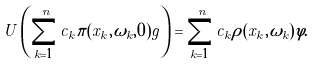<formula> <loc_0><loc_0><loc_500><loc_500>U \left ( \sum _ { k = 1 } ^ { n } c _ { k } \pi ( x _ { k } , \omega _ { k } , 0 ) g \right ) = \sum _ { k = 1 } ^ { n } c _ { k } \rho ( x _ { k } , \omega _ { k } ) \varphi .</formula> 